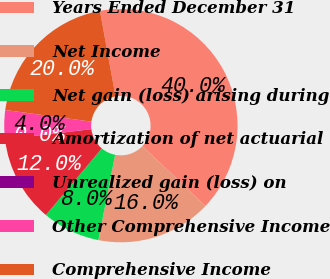Convert chart to OTSL. <chart><loc_0><loc_0><loc_500><loc_500><pie_chart><fcel>Years Ended December 31<fcel>Net Income<fcel>Net gain (loss) arising during<fcel>Amortization of net actuarial<fcel>Unrealized gain (loss) on<fcel>Other Comprehensive Income<fcel>Comprehensive Income<nl><fcel>39.96%<fcel>16.0%<fcel>8.01%<fcel>12.0%<fcel>0.02%<fcel>4.01%<fcel>19.99%<nl></chart> 